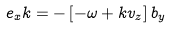Convert formula to latex. <formula><loc_0><loc_0><loc_500><loc_500>e _ { x } k = - \left [ { - \omega + k v _ { z } } \right ] b _ { y }</formula> 